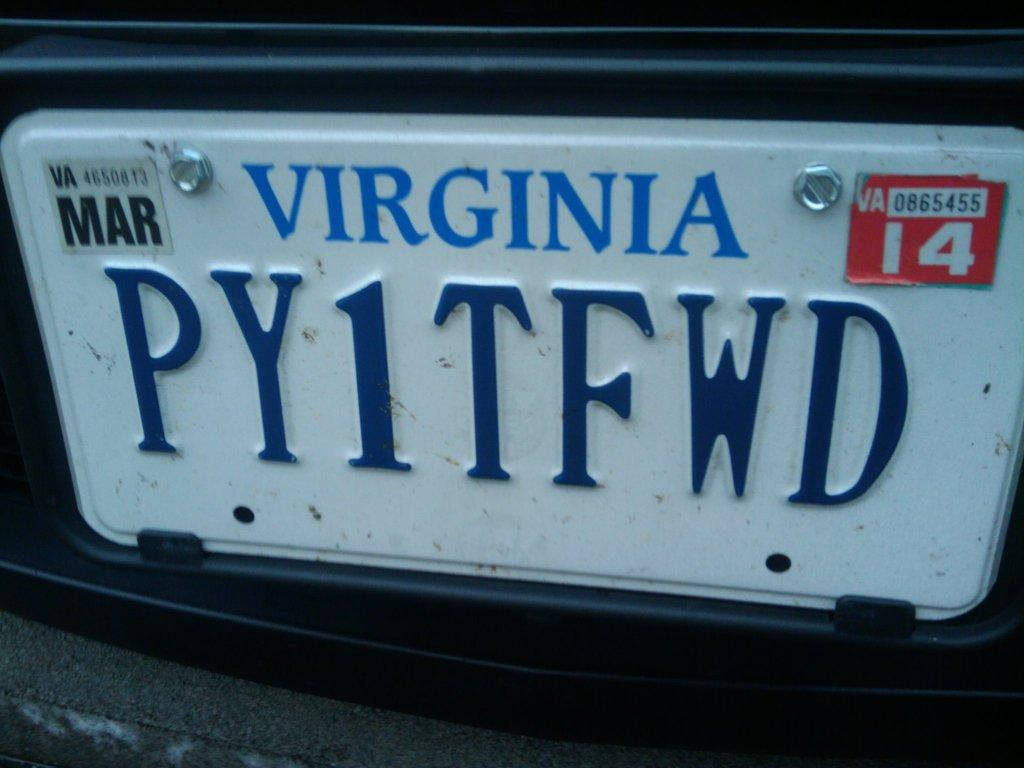Provide a one-sentence caption for the provided image. A close up of a Viriginia licence plate PY1TFWD. 